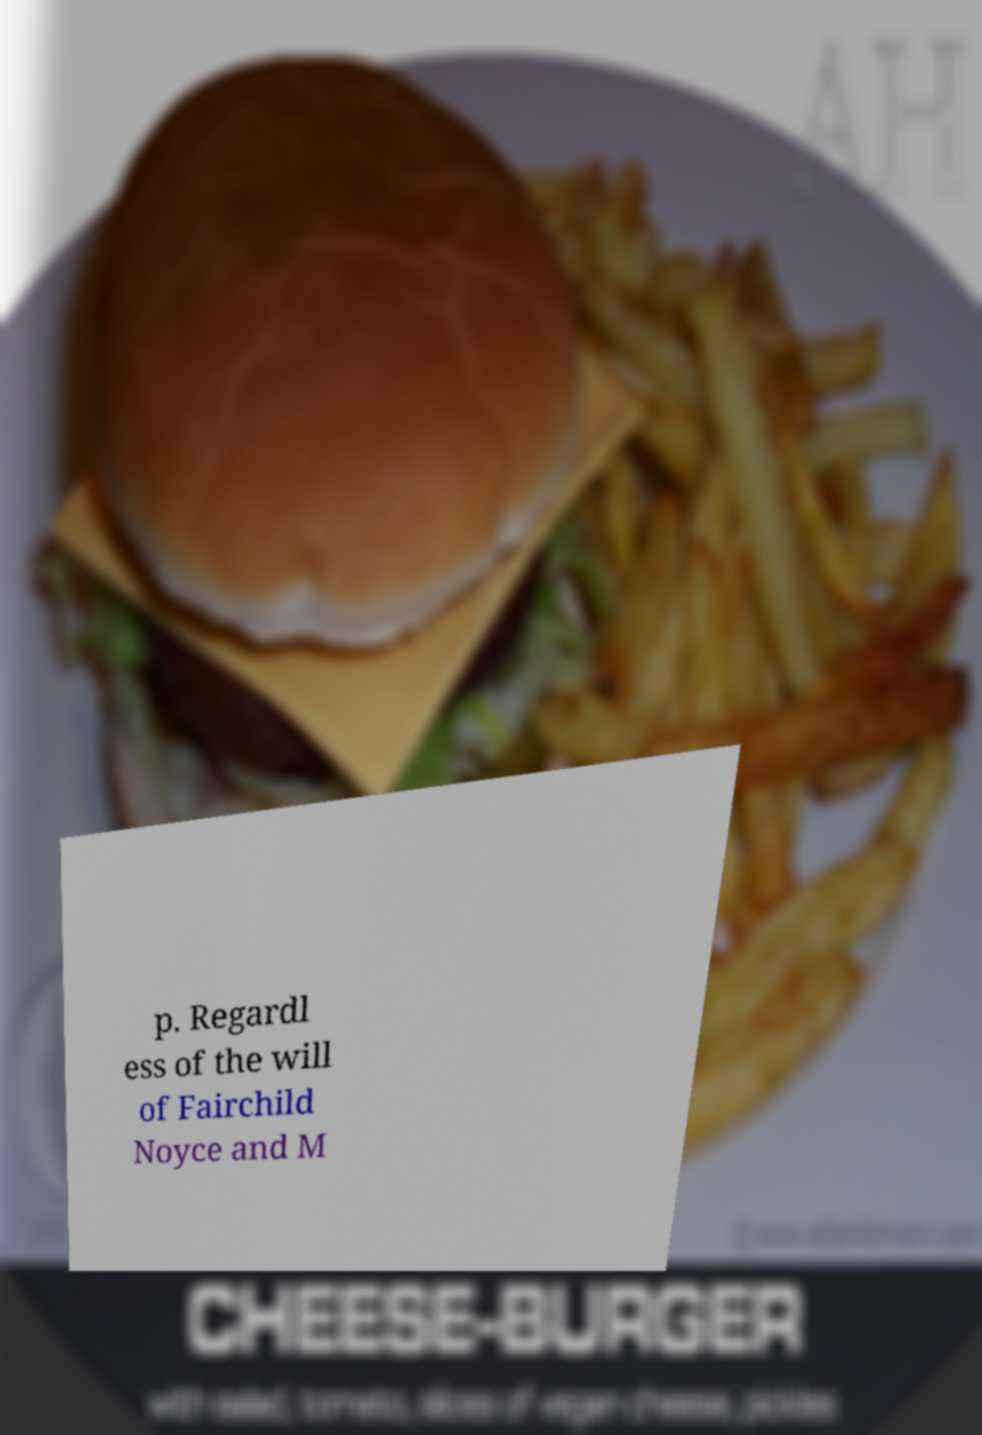Can you accurately transcribe the text from the provided image for me? p. Regardl ess of the will of Fairchild Noyce and M 